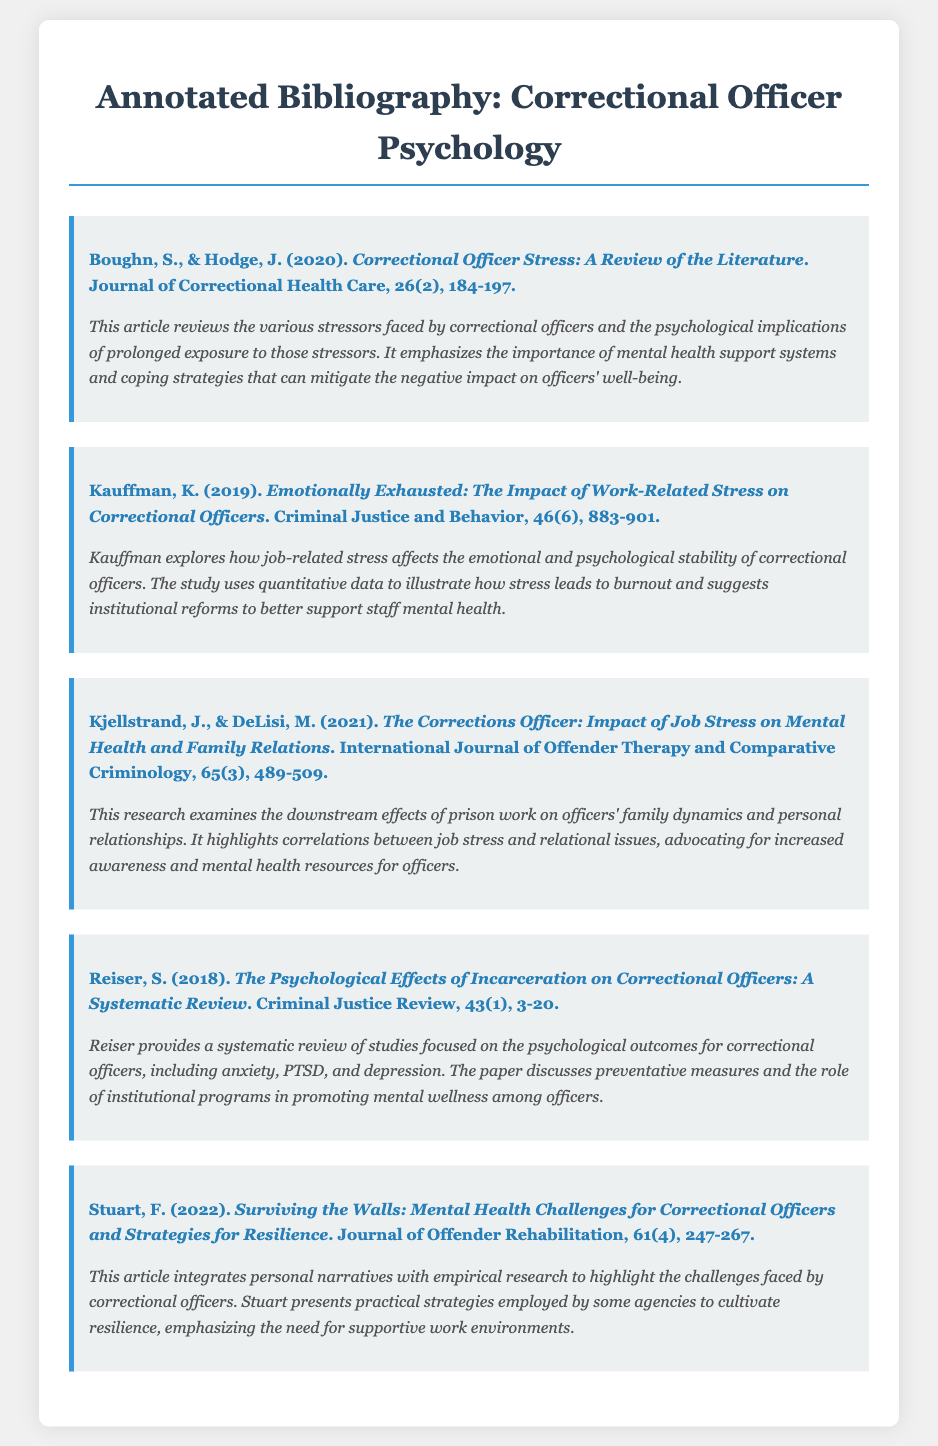What is the title of the article by Boughn and Hodge? The title of the article is provided in the citation section, which states "Correctional Officer Stress: A Review of the Literature".
Answer: Correctional Officer Stress: A Review of the Literature What year was Kauffman's article published? The publication year can be found in the citation, which indicates it was published in 2019.
Answer: 2019 How many pages does Reiser's article span? The pagination in the citation indicates the article spans from page 3 to 20, giving a total of 18 pages.
Answer: 18 What is the main focus of Kjellstrand and DeLisi's research? The summary states that the research examines the downstream effects of prison work on officers' family dynamics and personal relationships.
Answer: Family dynamics and personal relationships Which journal published the article by Stuart? The citation indicates that the article was published in the Journal of Offender Rehabilitation.
Answer: Journal of Offender Rehabilitation What type of review does Reiser's article provide? The summary categorizes the article as a systematic review of studies focused on psychological outcomes for correctional officers.
Answer: Systematic review How many authors contributed to the article on stress by Boughn and Hodge? The citation shows that there are two authors listed for the article.
Answer: Two What is one strategy suggested by Stuart for resilience among correctional officers? The summary indicates that practical strategies employed by some agencies to cultivate resilience are discussed, but does not specify one.
Answer: Practical strategies (specific not provided) 